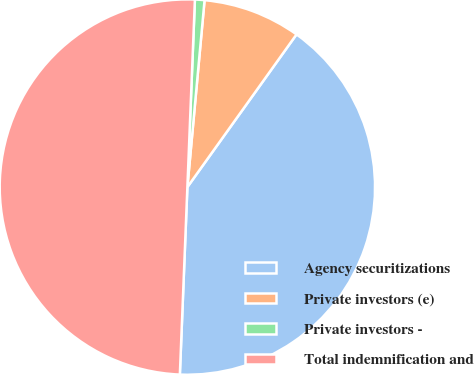<chart> <loc_0><loc_0><loc_500><loc_500><pie_chart><fcel>Agency securitizations<fcel>Private investors (e)<fcel>Private investors -<fcel>Total indemnification and<nl><fcel>40.76%<fcel>8.42%<fcel>0.82%<fcel>50.0%<nl></chart> 